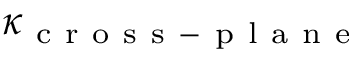<formula> <loc_0><loc_0><loc_500><loc_500>\kappa _ { c r o s s - p l a n e }</formula> 